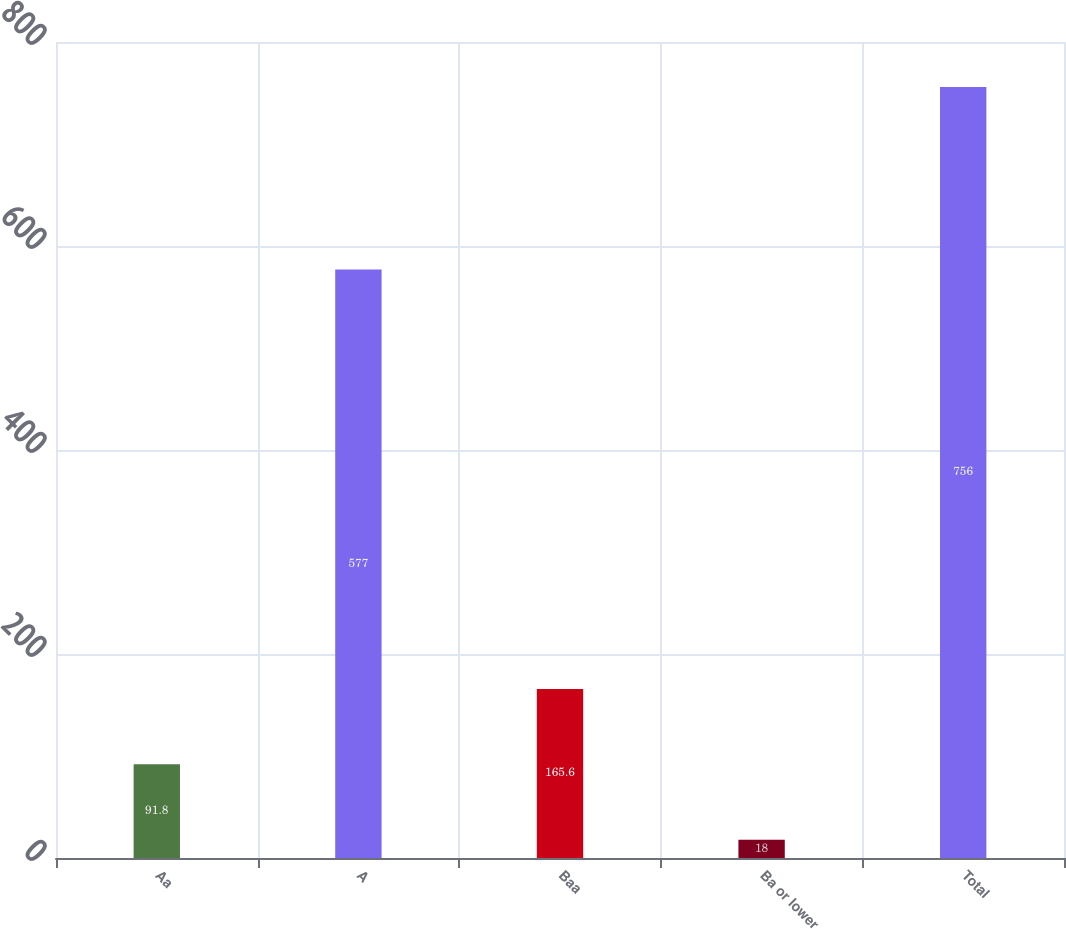Convert chart to OTSL. <chart><loc_0><loc_0><loc_500><loc_500><bar_chart><fcel>Aa<fcel>A<fcel>Baa<fcel>Ba or lower<fcel>Total<nl><fcel>91.8<fcel>577<fcel>165.6<fcel>18<fcel>756<nl></chart> 